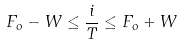Convert formula to latex. <formula><loc_0><loc_0><loc_500><loc_500>F _ { o } - W \leq \frac { i } { T } \leq F _ { o } + W</formula> 